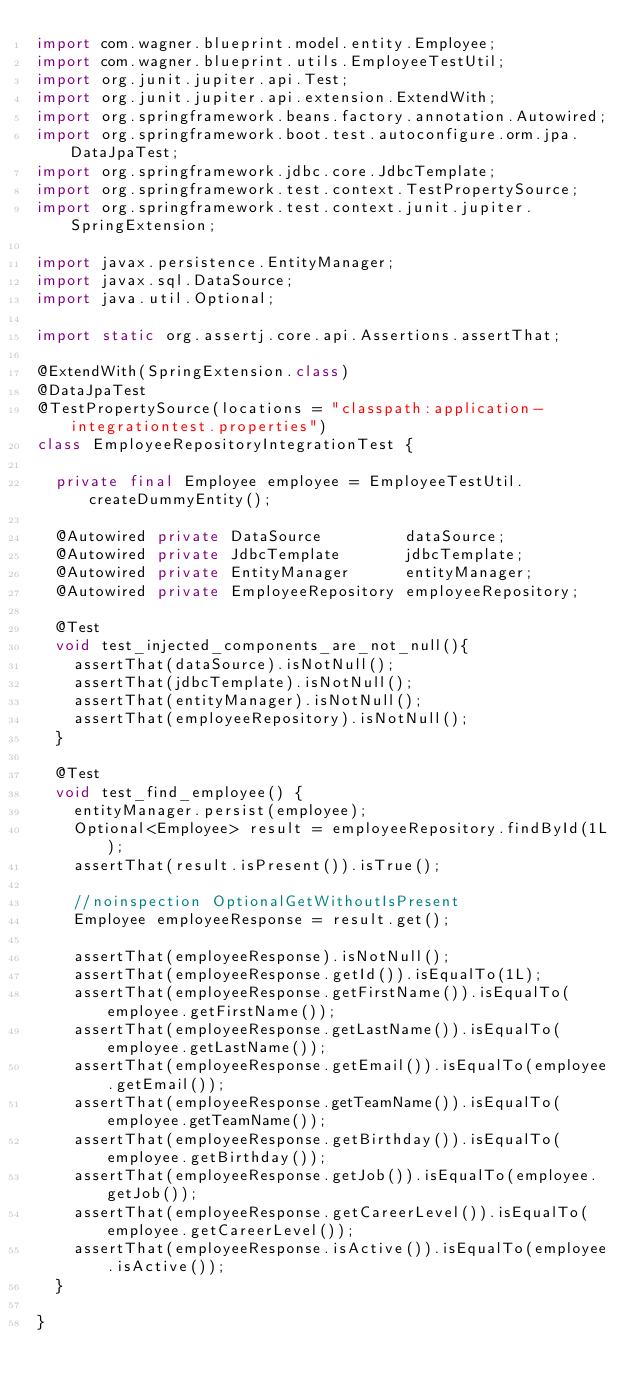<code> <loc_0><loc_0><loc_500><loc_500><_Java_>import com.wagner.blueprint.model.entity.Employee;
import com.wagner.blueprint.utils.EmployeeTestUtil;
import org.junit.jupiter.api.Test;
import org.junit.jupiter.api.extension.ExtendWith;
import org.springframework.beans.factory.annotation.Autowired;
import org.springframework.boot.test.autoconfigure.orm.jpa.DataJpaTest;
import org.springframework.jdbc.core.JdbcTemplate;
import org.springframework.test.context.TestPropertySource;
import org.springframework.test.context.junit.jupiter.SpringExtension;

import javax.persistence.EntityManager;
import javax.sql.DataSource;
import java.util.Optional;

import static org.assertj.core.api.Assertions.assertThat;

@ExtendWith(SpringExtension.class)
@DataJpaTest
@TestPropertySource(locations = "classpath:application-integrationtest.properties")
class EmployeeRepositoryIntegrationTest {

  private final Employee employee = EmployeeTestUtil.createDummyEntity();

  @Autowired private DataSource         dataSource;
  @Autowired private JdbcTemplate       jdbcTemplate;
  @Autowired private EntityManager      entityManager;
  @Autowired private EmployeeRepository employeeRepository;

  @Test
  void test_injected_components_are_not_null(){
    assertThat(dataSource).isNotNull();
    assertThat(jdbcTemplate).isNotNull();
    assertThat(entityManager).isNotNull();
    assertThat(employeeRepository).isNotNull();
  }

  @Test
  void test_find_employee() {
    entityManager.persist(employee);
    Optional<Employee> result = employeeRepository.findById(1L);
    assertThat(result.isPresent()).isTrue();

    //noinspection OptionalGetWithoutIsPresent
    Employee employeeResponse = result.get();

    assertThat(employeeResponse).isNotNull();
    assertThat(employeeResponse.getId()).isEqualTo(1L);
    assertThat(employeeResponse.getFirstName()).isEqualTo(employee.getFirstName());
    assertThat(employeeResponse.getLastName()).isEqualTo(employee.getLastName());
    assertThat(employeeResponse.getEmail()).isEqualTo(employee.getEmail());
    assertThat(employeeResponse.getTeamName()).isEqualTo(employee.getTeamName());
    assertThat(employeeResponse.getBirthday()).isEqualTo(employee.getBirthday());
    assertThat(employeeResponse.getJob()).isEqualTo(employee.getJob());
    assertThat(employeeResponse.getCareerLevel()).isEqualTo(employee.getCareerLevel());
    assertThat(employeeResponse.isActive()).isEqualTo(employee.isActive());
  }

}</code> 